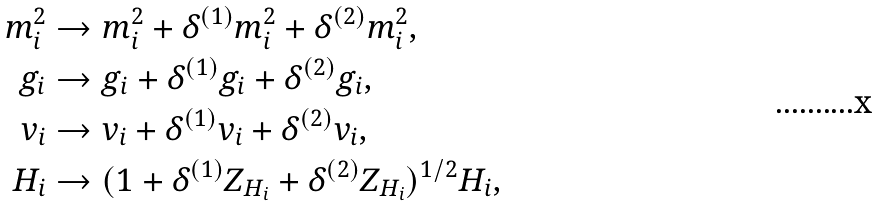Convert formula to latex. <formula><loc_0><loc_0><loc_500><loc_500>m _ { i } ^ { 2 } & \to m _ { i } ^ { 2 } + \delta ^ { ( 1 ) } m _ { i } ^ { 2 } + \delta ^ { ( 2 ) } m _ { i } ^ { 2 } , \\ g _ { i } & \to g _ { i } + \delta ^ { ( 1 ) } g _ { i } + \delta ^ { ( 2 ) } g _ { i } , \\ v _ { i } & \to v _ { i } + \delta ^ { ( 1 ) } v _ { i } + \delta ^ { ( 2 ) } v _ { i } , \\ H _ { i } & \to ( 1 + \delta ^ { ( 1 ) } Z _ { H _ { i } } + \delta ^ { ( 2 ) } Z _ { H _ { i } } ) ^ { 1 / 2 } H _ { i } ,</formula> 